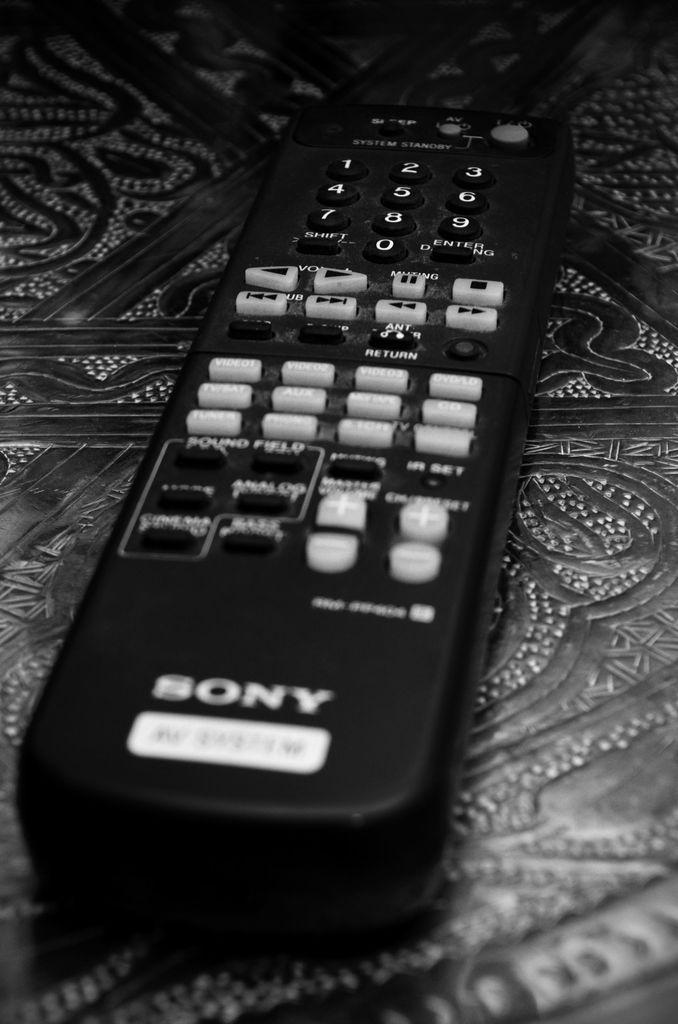<image>
Summarize the visual content of the image. A sony remote is laying across a detailed table. 